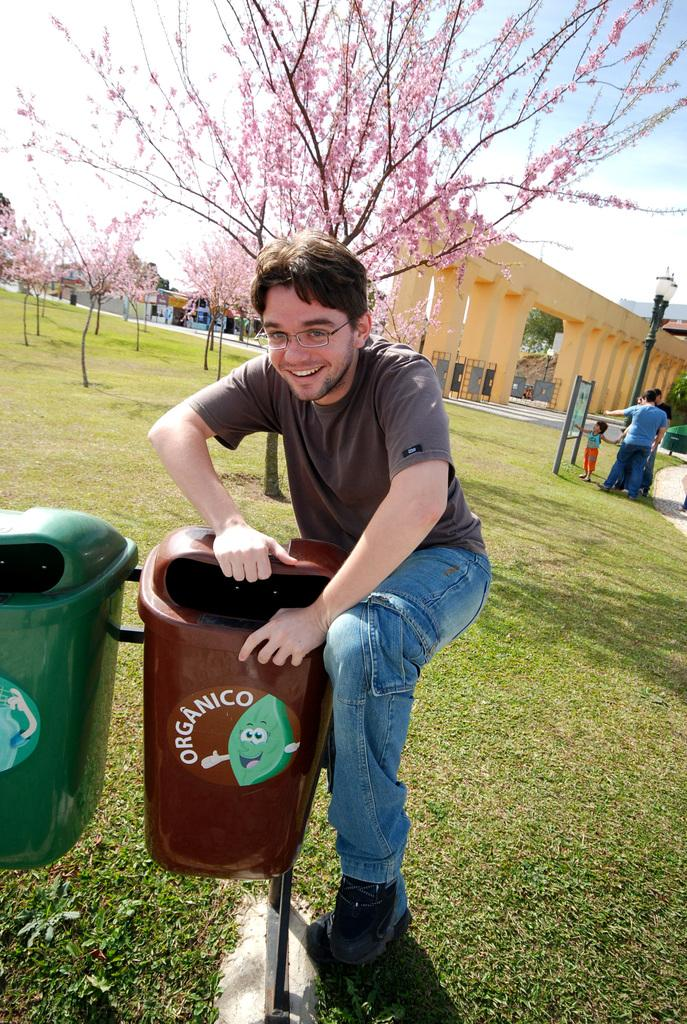<image>
Share a concise interpretation of the image provided. A man posing with a trash can that says "Organico" on it. 